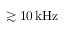<formula> <loc_0><loc_0><loc_500><loc_500>\gtrsim 1 0 \, k H z</formula> 